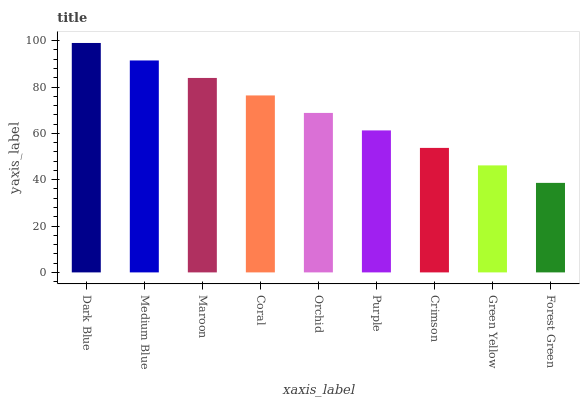Is Forest Green the minimum?
Answer yes or no. Yes. Is Dark Blue the maximum?
Answer yes or no. Yes. Is Medium Blue the minimum?
Answer yes or no. No. Is Medium Blue the maximum?
Answer yes or no. No. Is Dark Blue greater than Medium Blue?
Answer yes or no. Yes. Is Medium Blue less than Dark Blue?
Answer yes or no. Yes. Is Medium Blue greater than Dark Blue?
Answer yes or no. No. Is Dark Blue less than Medium Blue?
Answer yes or no. No. Is Orchid the high median?
Answer yes or no. Yes. Is Orchid the low median?
Answer yes or no. Yes. Is Crimson the high median?
Answer yes or no. No. Is Crimson the low median?
Answer yes or no. No. 